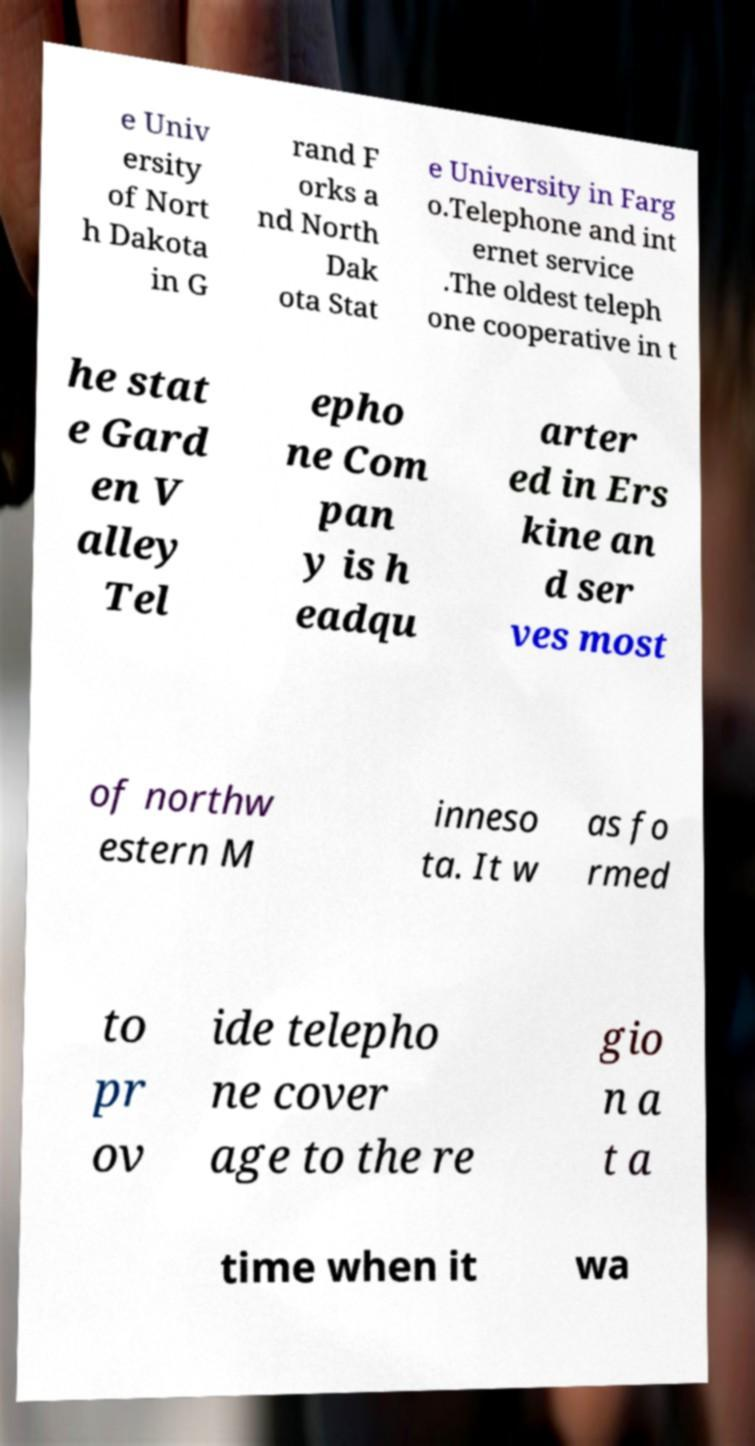There's text embedded in this image that I need extracted. Can you transcribe it verbatim? e Univ ersity of Nort h Dakota in G rand F orks a nd North Dak ota Stat e University in Farg o.Telephone and int ernet service .The oldest teleph one cooperative in t he stat e Gard en V alley Tel epho ne Com pan y is h eadqu arter ed in Ers kine an d ser ves most of northw estern M inneso ta. It w as fo rmed to pr ov ide telepho ne cover age to the re gio n a t a time when it wa 